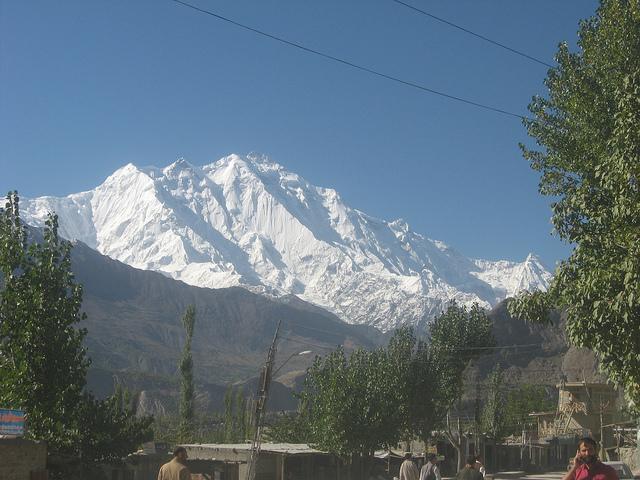How many benches are in the photo?
Give a very brief answer. 0. 